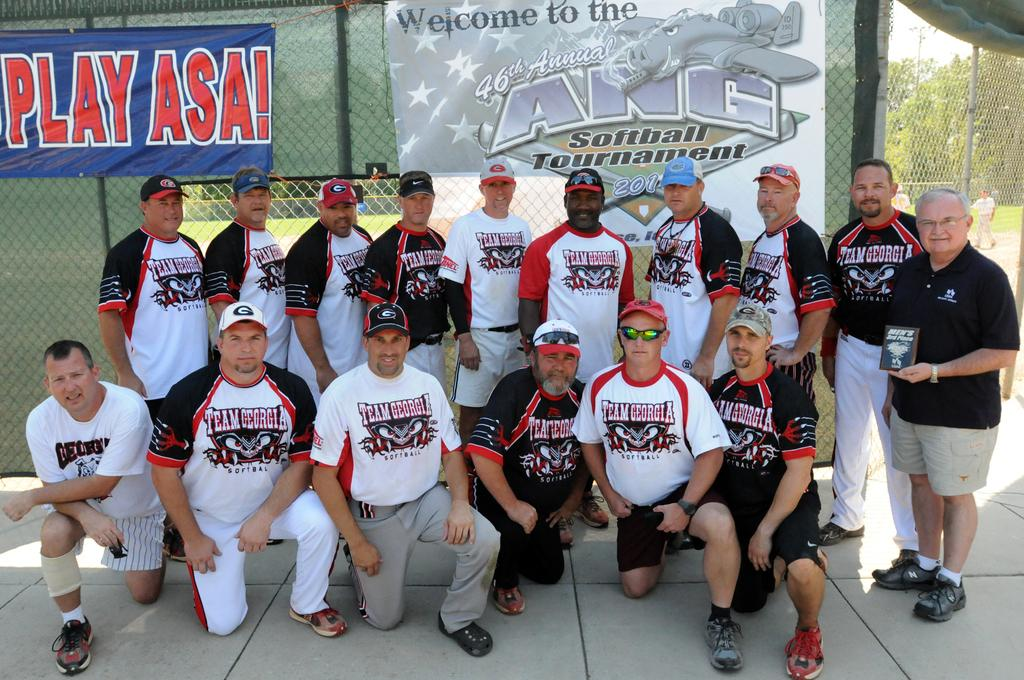<image>
Describe the image concisely. Team Georgia members are posed for the 46th annual ANG Softball Tournament. 